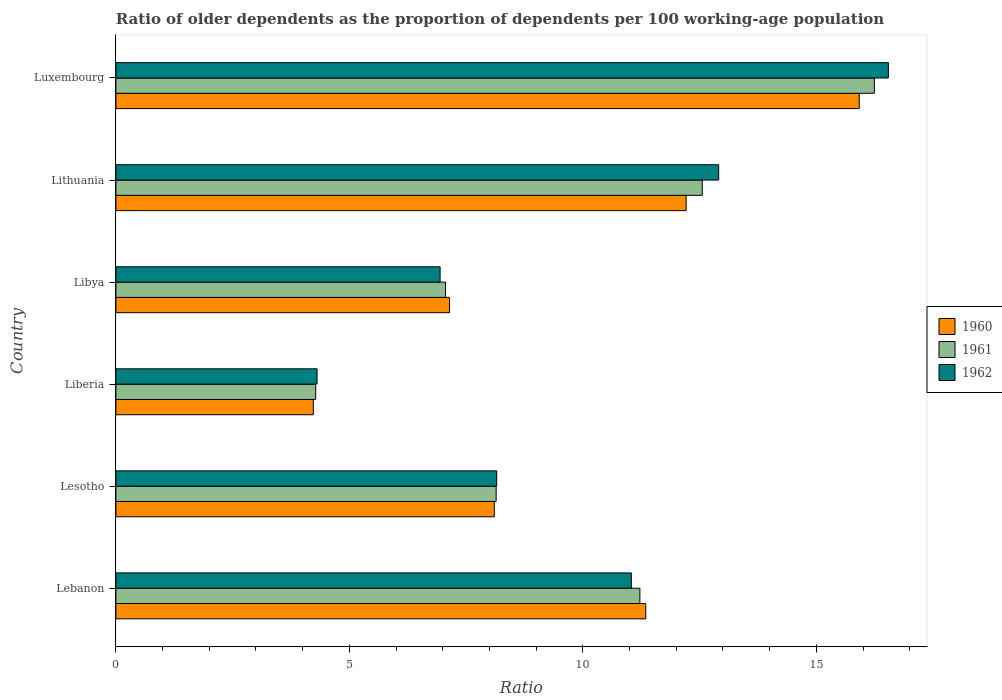How many bars are there on the 4th tick from the top?
Your answer should be compact. 3. What is the label of the 6th group of bars from the top?
Provide a succinct answer. Lebanon. What is the age dependency ratio(old) in 1960 in Lesotho?
Your answer should be compact. 8.1. Across all countries, what is the maximum age dependency ratio(old) in 1962?
Your answer should be very brief. 16.54. Across all countries, what is the minimum age dependency ratio(old) in 1962?
Your response must be concise. 4.31. In which country was the age dependency ratio(old) in 1960 maximum?
Give a very brief answer. Luxembourg. In which country was the age dependency ratio(old) in 1961 minimum?
Your response must be concise. Liberia. What is the total age dependency ratio(old) in 1962 in the graph?
Make the answer very short. 59.9. What is the difference between the age dependency ratio(old) in 1961 in Liberia and that in Libya?
Ensure brevity in your answer.  -2.78. What is the difference between the age dependency ratio(old) in 1961 in Liberia and the age dependency ratio(old) in 1960 in Lithuania?
Provide a succinct answer. -7.93. What is the average age dependency ratio(old) in 1960 per country?
Ensure brevity in your answer.  9.83. What is the difference between the age dependency ratio(old) in 1962 and age dependency ratio(old) in 1961 in Lesotho?
Keep it short and to the point. 0.01. In how many countries, is the age dependency ratio(old) in 1962 greater than 9 ?
Give a very brief answer. 3. What is the ratio of the age dependency ratio(old) in 1960 in Lebanon to that in Libya?
Offer a very short reply. 1.59. Is the age dependency ratio(old) in 1960 in Lebanon less than that in Lithuania?
Provide a succinct answer. Yes. Is the difference between the age dependency ratio(old) in 1962 in Liberia and Libya greater than the difference between the age dependency ratio(old) in 1961 in Liberia and Libya?
Keep it short and to the point. Yes. What is the difference between the highest and the second highest age dependency ratio(old) in 1960?
Your answer should be very brief. 3.71. What is the difference between the highest and the lowest age dependency ratio(old) in 1960?
Provide a succinct answer. 11.69. Is the sum of the age dependency ratio(old) in 1962 in Lithuania and Luxembourg greater than the maximum age dependency ratio(old) in 1961 across all countries?
Give a very brief answer. Yes. What does the 2nd bar from the bottom in Libya represents?
Give a very brief answer. 1961. Are all the bars in the graph horizontal?
Provide a short and direct response. Yes. How many countries are there in the graph?
Ensure brevity in your answer.  6. What is the difference between two consecutive major ticks on the X-axis?
Provide a short and direct response. 5. Are the values on the major ticks of X-axis written in scientific E-notation?
Give a very brief answer. No. Does the graph contain grids?
Your answer should be very brief. No. Where does the legend appear in the graph?
Offer a terse response. Center right. What is the title of the graph?
Offer a very short reply. Ratio of older dependents as the proportion of dependents per 100 working-age population. Does "1973" appear as one of the legend labels in the graph?
Ensure brevity in your answer.  No. What is the label or title of the X-axis?
Provide a short and direct response. Ratio. What is the label or title of the Y-axis?
Provide a short and direct response. Country. What is the Ratio of 1960 in Lebanon?
Give a very brief answer. 11.35. What is the Ratio of 1961 in Lebanon?
Provide a short and direct response. 11.22. What is the Ratio of 1962 in Lebanon?
Ensure brevity in your answer.  11.04. What is the Ratio in 1960 in Lesotho?
Ensure brevity in your answer.  8.1. What is the Ratio in 1961 in Lesotho?
Make the answer very short. 8.14. What is the Ratio of 1962 in Lesotho?
Your answer should be very brief. 8.15. What is the Ratio in 1960 in Liberia?
Make the answer very short. 4.23. What is the Ratio of 1961 in Liberia?
Provide a succinct answer. 4.28. What is the Ratio of 1962 in Liberia?
Offer a very short reply. 4.31. What is the Ratio in 1960 in Libya?
Ensure brevity in your answer.  7.14. What is the Ratio of 1961 in Libya?
Your answer should be compact. 7.06. What is the Ratio of 1962 in Libya?
Give a very brief answer. 6.94. What is the Ratio in 1960 in Lithuania?
Keep it short and to the point. 12.21. What is the Ratio of 1961 in Lithuania?
Make the answer very short. 12.56. What is the Ratio of 1962 in Lithuania?
Your answer should be very brief. 12.91. What is the Ratio of 1960 in Luxembourg?
Keep it short and to the point. 15.92. What is the Ratio in 1961 in Luxembourg?
Your answer should be very brief. 16.24. What is the Ratio in 1962 in Luxembourg?
Your answer should be compact. 16.54. Across all countries, what is the maximum Ratio of 1960?
Ensure brevity in your answer.  15.92. Across all countries, what is the maximum Ratio of 1961?
Offer a terse response. 16.24. Across all countries, what is the maximum Ratio of 1962?
Make the answer very short. 16.54. Across all countries, what is the minimum Ratio of 1960?
Make the answer very short. 4.23. Across all countries, what is the minimum Ratio of 1961?
Offer a terse response. 4.28. Across all countries, what is the minimum Ratio of 1962?
Give a very brief answer. 4.31. What is the total Ratio in 1960 in the graph?
Make the answer very short. 58.95. What is the total Ratio of 1961 in the graph?
Provide a succinct answer. 59.5. What is the total Ratio in 1962 in the graph?
Make the answer very short. 59.9. What is the difference between the Ratio in 1960 in Lebanon and that in Lesotho?
Your response must be concise. 3.24. What is the difference between the Ratio of 1961 in Lebanon and that in Lesotho?
Give a very brief answer. 3.08. What is the difference between the Ratio of 1962 in Lebanon and that in Lesotho?
Your answer should be very brief. 2.88. What is the difference between the Ratio in 1960 in Lebanon and that in Liberia?
Provide a succinct answer. 7.12. What is the difference between the Ratio of 1961 in Lebanon and that in Liberia?
Your answer should be very brief. 6.94. What is the difference between the Ratio of 1962 in Lebanon and that in Liberia?
Your answer should be very brief. 6.73. What is the difference between the Ratio in 1960 in Lebanon and that in Libya?
Your answer should be very brief. 4.2. What is the difference between the Ratio of 1961 in Lebanon and that in Libya?
Offer a very short reply. 4.16. What is the difference between the Ratio in 1962 in Lebanon and that in Libya?
Offer a very short reply. 4.09. What is the difference between the Ratio of 1960 in Lebanon and that in Lithuania?
Your response must be concise. -0.86. What is the difference between the Ratio of 1961 in Lebanon and that in Lithuania?
Offer a very short reply. -1.34. What is the difference between the Ratio of 1962 in Lebanon and that in Lithuania?
Offer a terse response. -1.87. What is the difference between the Ratio of 1960 in Lebanon and that in Luxembourg?
Offer a terse response. -4.57. What is the difference between the Ratio in 1961 in Lebanon and that in Luxembourg?
Provide a succinct answer. -5.02. What is the difference between the Ratio in 1962 in Lebanon and that in Luxembourg?
Provide a succinct answer. -5.5. What is the difference between the Ratio of 1960 in Lesotho and that in Liberia?
Ensure brevity in your answer.  3.88. What is the difference between the Ratio of 1961 in Lesotho and that in Liberia?
Your answer should be very brief. 3.86. What is the difference between the Ratio of 1962 in Lesotho and that in Liberia?
Your response must be concise. 3.85. What is the difference between the Ratio of 1960 in Lesotho and that in Libya?
Keep it short and to the point. 0.96. What is the difference between the Ratio in 1961 in Lesotho and that in Libya?
Your answer should be compact. 1.08. What is the difference between the Ratio of 1962 in Lesotho and that in Libya?
Provide a short and direct response. 1.21. What is the difference between the Ratio of 1960 in Lesotho and that in Lithuania?
Give a very brief answer. -4.11. What is the difference between the Ratio in 1961 in Lesotho and that in Lithuania?
Offer a very short reply. -4.41. What is the difference between the Ratio in 1962 in Lesotho and that in Lithuania?
Offer a very short reply. -4.75. What is the difference between the Ratio of 1960 in Lesotho and that in Luxembourg?
Make the answer very short. -7.82. What is the difference between the Ratio in 1961 in Lesotho and that in Luxembourg?
Your answer should be compact. -8.1. What is the difference between the Ratio in 1962 in Lesotho and that in Luxembourg?
Provide a short and direct response. -8.39. What is the difference between the Ratio of 1960 in Liberia and that in Libya?
Give a very brief answer. -2.92. What is the difference between the Ratio in 1961 in Liberia and that in Libya?
Your answer should be compact. -2.78. What is the difference between the Ratio of 1962 in Liberia and that in Libya?
Provide a succinct answer. -2.64. What is the difference between the Ratio in 1960 in Liberia and that in Lithuania?
Make the answer very short. -7.98. What is the difference between the Ratio in 1961 in Liberia and that in Lithuania?
Your response must be concise. -8.28. What is the difference between the Ratio of 1962 in Liberia and that in Lithuania?
Keep it short and to the point. -8.6. What is the difference between the Ratio in 1960 in Liberia and that in Luxembourg?
Make the answer very short. -11.69. What is the difference between the Ratio in 1961 in Liberia and that in Luxembourg?
Your answer should be compact. -11.96. What is the difference between the Ratio of 1962 in Liberia and that in Luxembourg?
Your answer should be very brief. -12.23. What is the difference between the Ratio of 1960 in Libya and that in Lithuania?
Offer a terse response. -5.07. What is the difference between the Ratio of 1961 in Libya and that in Lithuania?
Your response must be concise. -5.5. What is the difference between the Ratio in 1962 in Libya and that in Lithuania?
Provide a succinct answer. -5.97. What is the difference between the Ratio of 1960 in Libya and that in Luxembourg?
Your answer should be very brief. -8.77. What is the difference between the Ratio in 1961 in Libya and that in Luxembourg?
Ensure brevity in your answer.  -9.18. What is the difference between the Ratio of 1962 in Libya and that in Luxembourg?
Your answer should be very brief. -9.6. What is the difference between the Ratio in 1960 in Lithuania and that in Luxembourg?
Provide a short and direct response. -3.71. What is the difference between the Ratio of 1961 in Lithuania and that in Luxembourg?
Keep it short and to the point. -3.69. What is the difference between the Ratio in 1962 in Lithuania and that in Luxembourg?
Make the answer very short. -3.63. What is the difference between the Ratio of 1960 in Lebanon and the Ratio of 1961 in Lesotho?
Offer a very short reply. 3.2. What is the difference between the Ratio of 1960 in Lebanon and the Ratio of 1962 in Lesotho?
Give a very brief answer. 3.19. What is the difference between the Ratio of 1961 in Lebanon and the Ratio of 1962 in Lesotho?
Offer a very short reply. 3.07. What is the difference between the Ratio in 1960 in Lebanon and the Ratio in 1961 in Liberia?
Offer a terse response. 7.07. What is the difference between the Ratio in 1960 in Lebanon and the Ratio in 1962 in Liberia?
Provide a succinct answer. 7.04. What is the difference between the Ratio of 1961 in Lebanon and the Ratio of 1962 in Liberia?
Your answer should be very brief. 6.91. What is the difference between the Ratio in 1960 in Lebanon and the Ratio in 1961 in Libya?
Offer a terse response. 4.29. What is the difference between the Ratio in 1960 in Lebanon and the Ratio in 1962 in Libya?
Provide a succinct answer. 4.4. What is the difference between the Ratio in 1961 in Lebanon and the Ratio in 1962 in Libya?
Provide a short and direct response. 4.28. What is the difference between the Ratio in 1960 in Lebanon and the Ratio in 1961 in Lithuania?
Provide a succinct answer. -1.21. What is the difference between the Ratio in 1960 in Lebanon and the Ratio in 1962 in Lithuania?
Your response must be concise. -1.56. What is the difference between the Ratio in 1961 in Lebanon and the Ratio in 1962 in Lithuania?
Make the answer very short. -1.69. What is the difference between the Ratio in 1960 in Lebanon and the Ratio in 1961 in Luxembourg?
Ensure brevity in your answer.  -4.89. What is the difference between the Ratio of 1960 in Lebanon and the Ratio of 1962 in Luxembourg?
Give a very brief answer. -5.2. What is the difference between the Ratio of 1961 in Lebanon and the Ratio of 1962 in Luxembourg?
Keep it short and to the point. -5.32. What is the difference between the Ratio in 1960 in Lesotho and the Ratio in 1961 in Liberia?
Give a very brief answer. 3.83. What is the difference between the Ratio of 1960 in Lesotho and the Ratio of 1962 in Liberia?
Your response must be concise. 3.8. What is the difference between the Ratio of 1961 in Lesotho and the Ratio of 1962 in Liberia?
Offer a very short reply. 3.83. What is the difference between the Ratio in 1960 in Lesotho and the Ratio in 1961 in Libya?
Your answer should be compact. 1.05. What is the difference between the Ratio of 1960 in Lesotho and the Ratio of 1962 in Libya?
Your response must be concise. 1.16. What is the difference between the Ratio in 1961 in Lesotho and the Ratio in 1962 in Libya?
Ensure brevity in your answer.  1.2. What is the difference between the Ratio in 1960 in Lesotho and the Ratio in 1961 in Lithuania?
Give a very brief answer. -4.45. What is the difference between the Ratio of 1960 in Lesotho and the Ratio of 1962 in Lithuania?
Keep it short and to the point. -4.8. What is the difference between the Ratio of 1961 in Lesotho and the Ratio of 1962 in Lithuania?
Make the answer very short. -4.77. What is the difference between the Ratio in 1960 in Lesotho and the Ratio in 1961 in Luxembourg?
Offer a terse response. -8.14. What is the difference between the Ratio in 1960 in Lesotho and the Ratio in 1962 in Luxembourg?
Your response must be concise. -8.44. What is the difference between the Ratio of 1961 in Lesotho and the Ratio of 1962 in Luxembourg?
Provide a succinct answer. -8.4. What is the difference between the Ratio of 1960 in Liberia and the Ratio of 1961 in Libya?
Make the answer very short. -2.83. What is the difference between the Ratio in 1960 in Liberia and the Ratio in 1962 in Libya?
Offer a terse response. -2.71. What is the difference between the Ratio of 1961 in Liberia and the Ratio of 1962 in Libya?
Provide a succinct answer. -2.66. What is the difference between the Ratio in 1960 in Liberia and the Ratio in 1961 in Lithuania?
Keep it short and to the point. -8.33. What is the difference between the Ratio in 1960 in Liberia and the Ratio in 1962 in Lithuania?
Give a very brief answer. -8.68. What is the difference between the Ratio of 1961 in Liberia and the Ratio of 1962 in Lithuania?
Your response must be concise. -8.63. What is the difference between the Ratio of 1960 in Liberia and the Ratio of 1961 in Luxembourg?
Offer a terse response. -12.01. What is the difference between the Ratio of 1960 in Liberia and the Ratio of 1962 in Luxembourg?
Your response must be concise. -12.31. What is the difference between the Ratio of 1961 in Liberia and the Ratio of 1962 in Luxembourg?
Your response must be concise. -12.26. What is the difference between the Ratio in 1960 in Libya and the Ratio in 1961 in Lithuania?
Ensure brevity in your answer.  -5.41. What is the difference between the Ratio in 1960 in Libya and the Ratio in 1962 in Lithuania?
Give a very brief answer. -5.76. What is the difference between the Ratio in 1961 in Libya and the Ratio in 1962 in Lithuania?
Give a very brief answer. -5.85. What is the difference between the Ratio of 1960 in Libya and the Ratio of 1961 in Luxembourg?
Offer a very short reply. -9.1. What is the difference between the Ratio of 1960 in Libya and the Ratio of 1962 in Luxembourg?
Keep it short and to the point. -9.4. What is the difference between the Ratio in 1961 in Libya and the Ratio in 1962 in Luxembourg?
Provide a short and direct response. -9.48. What is the difference between the Ratio of 1960 in Lithuania and the Ratio of 1961 in Luxembourg?
Make the answer very short. -4.03. What is the difference between the Ratio in 1960 in Lithuania and the Ratio in 1962 in Luxembourg?
Your response must be concise. -4.33. What is the difference between the Ratio of 1961 in Lithuania and the Ratio of 1962 in Luxembourg?
Your response must be concise. -3.99. What is the average Ratio in 1960 per country?
Give a very brief answer. 9.83. What is the average Ratio in 1961 per country?
Make the answer very short. 9.92. What is the average Ratio of 1962 per country?
Your answer should be compact. 9.98. What is the difference between the Ratio in 1960 and Ratio in 1961 in Lebanon?
Your answer should be very brief. 0.13. What is the difference between the Ratio in 1960 and Ratio in 1962 in Lebanon?
Provide a short and direct response. 0.31. What is the difference between the Ratio in 1961 and Ratio in 1962 in Lebanon?
Make the answer very short. 0.18. What is the difference between the Ratio of 1960 and Ratio of 1961 in Lesotho?
Keep it short and to the point. -0.04. What is the difference between the Ratio in 1960 and Ratio in 1962 in Lesotho?
Make the answer very short. -0.05. What is the difference between the Ratio of 1961 and Ratio of 1962 in Lesotho?
Provide a short and direct response. -0.01. What is the difference between the Ratio of 1960 and Ratio of 1961 in Liberia?
Offer a very short reply. -0.05. What is the difference between the Ratio of 1960 and Ratio of 1962 in Liberia?
Provide a short and direct response. -0.08. What is the difference between the Ratio of 1961 and Ratio of 1962 in Liberia?
Offer a very short reply. -0.03. What is the difference between the Ratio of 1960 and Ratio of 1961 in Libya?
Make the answer very short. 0.09. What is the difference between the Ratio in 1960 and Ratio in 1962 in Libya?
Your answer should be very brief. 0.2. What is the difference between the Ratio in 1961 and Ratio in 1962 in Libya?
Your response must be concise. 0.12. What is the difference between the Ratio in 1960 and Ratio in 1961 in Lithuania?
Ensure brevity in your answer.  -0.35. What is the difference between the Ratio of 1960 and Ratio of 1962 in Lithuania?
Ensure brevity in your answer.  -0.7. What is the difference between the Ratio in 1961 and Ratio in 1962 in Lithuania?
Give a very brief answer. -0.35. What is the difference between the Ratio in 1960 and Ratio in 1961 in Luxembourg?
Make the answer very short. -0.32. What is the difference between the Ratio of 1960 and Ratio of 1962 in Luxembourg?
Keep it short and to the point. -0.62. What is the difference between the Ratio of 1961 and Ratio of 1962 in Luxembourg?
Give a very brief answer. -0.3. What is the ratio of the Ratio of 1960 in Lebanon to that in Lesotho?
Your answer should be compact. 1.4. What is the ratio of the Ratio of 1961 in Lebanon to that in Lesotho?
Keep it short and to the point. 1.38. What is the ratio of the Ratio in 1962 in Lebanon to that in Lesotho?
Your answer should be compact. 1.35. What is the ratio of the Ratio in 1960 in Lebanon to that in Liberia?
Give a very brief answer. 2.68. What is the ratio of the Ratio in 1961 in Lebanon to that in Liberia?
Provide a short and direct response. 2.62. What is the ratio of the Ratio of 1962 in Lebanon to that in Liberia?
Your response must be concise. 2.56. What is the ratio of the Ratio in 1960 in Lebanon to that in Libya?
Your answer should be compact. 1.59. What is the ratio of the Ratio of 1961 in Lebanon to that in Libya?
Provide a succinct answer. 1.59. What is the ratio of the Ratio in 1962 in Lebanon to that in Libya?
Make the answer very short. 1.59. What is the ratio of the Ratio in 1960 in Lebanon to that in Lithuania?
Offer a terse response. 0.93. What is the ratio of the Ratio in 1961 in Lebanon to that in Lithuania?
Keep it short and to the point. 0.89. What is the ratio of the Ratio of 1962 in Lebanon to that in Lithuania?
Your answer should be very brief. 0.86. What is the ratio of the Ratio of 1960 in Lebanon to that in Luxembourg?
Offer a very short reply. 0.71. What is the ratio of the Ratio of 1961 in Lebanon to that in Luxembourg?
Offer a very short reply. 0.69. What is the ratio of the Ratio in 1962 in Lebanon to that in Luxembourg?
Offer a terse response. 0.67. What is the ratio of the Ratio in 1960 in Lesotho to that in Liberia?
Offer a very short reply. 1.92. What is the ratio of the Ratio of 1961 in Lesotho to that in Liberia?
Offer a terse response. 1.9. What is the ratio of the Ratio of 1962 in Lesotho to that in Liberia?
Your response must be concise. 1.89. What is the ratio of the Ratio in 1960 in Lesotho to that in Libya?
Offer a very short reply. 1.13. What is the ratio of the Ratio of 1961 in Lesotho to that in Libya?
Keep it short and to the point. 1.15. What is the ratio of the Ratio of 1962 in Lesotho to that in Libya?
Your answer should be compact. 1.17. What is the ratio of the Ratio in 1960 in Lesotho to that in Lithuania?
Provide a short and direct response. 0.66. What is the ratio of the Ratio in 1961 in Lesotho to that in Lithuania?
Ensure brevity in your answer.  0.65. What is the ratio of the Ratio of 1962 in Lesotho to that in Lithuania?
Ensure brevity in your answer.  0.63. What is the ratio of the Ratio of 1960 in Lesotho to that in Luxembourg?
Your response must be concise. 0.51. What is the ratio of the Ratio in 1961 in Lesotho to that in Luxembourg?
Your answer should be very brief. 0.5. What is the ratio of the Ratio in 1962 in Lesotho to that in Luxembourg?
Give a very brief answer. 0.49. What is the ratio of the Ratio of 1960 in Liberia to that in Libya?
Offer a very short reply. 0.59. What is the ratio of the Ratio in 1961 in Liberia to that in Libya?
Give a very brief answer. 0.61. What is the ratio of the Ratio of 1962 in Liberia to that in Libya?
Make the answer very short. 0.62. What is the ratio of the Ratio in 1960 in Liberia to that in Lithuania?
Provide a short and direct response. 0.35. What is the ratio of the Ratio in 1961 in Liberia to that in Lithuania?
Make the answer very short. 0.34. What is the ratio of the Ratio in 1962 in Liberia to that in Lithuania?
Keep it short and to the point. 0.33. What is the ratio of the Ratio in 1960 in Liberia to that in Luxembourg?
Offer a very short reply. 0.27. What is the ratio of the Ratio in 1961 in Liberia to that in Luxembourg?
Your answer should be very brief. 0.26. What is the ratio of the Ratio in 1962 in Liberia to that in Luxembourg?
Provide a succinct answer. 0.26. What is the ratio of the Ratio of 1960 in Libya to that in Lithuania?
Your response must be concise. 0.58. What is the ratio of the Ratio of 1961 in Libya to that in Lithuania?
Offer a terse response. 0.56. What is the ratio of the Ratio of 1962 in Libya to that in Lithuania?
Ensure brevity in your answer.  0.54. What is the ratio of the Ratio of 1960 in Libya to that in Luxembourg?
Provide a short and direct response. 0.45. What is the ratio of the Ratio of 1961 in Libya to that in Luxembourg?
Give a very brief answer. 0.43. What is the ratio of the Ratio of 1962 in Libya to that in Luxembourg?
Provide a succinct answer. 0.42. What is the ratio of the Ratio in 1960 in Lithuania to that in Luxembourg?
Offer a very short reply. 0.77. What is the ratio of the Ratio of 1961 in Lithuania to that in Luxembourg?
Offer a very short reply. 0.77. What is the ratio of the Ratio of 1962 in Lithuania to that in Luxembourg?
Provide a short and direct response. 0.78. What is the difference between the highest and the second highest Ratio in 1960?
Offer a terse response. 3.71. What is the difference between the highest and the second highest Ratio of 1961?
Provide a succinct answer. 3.69. What is the difference between the highest and the second highest Ratio of 1962?
Ensure brevity in your answer.  3.63. What is the difference between the highest and the lowest Ratio in 1960?
Offer a terse response. 11.69. What is the difference between the highest and the lowest Ratio in 1961?
Your answer should be very brief. 11.96. What is the difference between the highest and the lowest Ratio of 1962?
Offer a terse response. 12.23. 